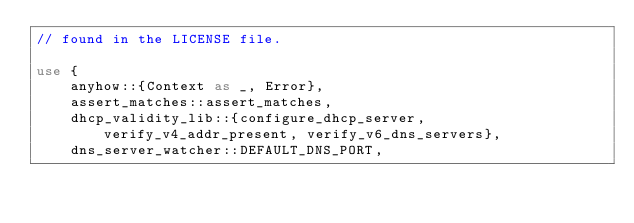<code> <loc_0><loc_0><loc_500><loc_500><_Rust_>// found in the LICENSE file.

use {
    anyhow::{Context as _, Error},
    assert_matches::assert_matches,
    dhcp_validity_lib::{configure_dhcp_server, verify_v4_addr_present, verify_v6_dns_servers},
    dns_server_watcher::DEFAULT_DNS_PORT,</code> 